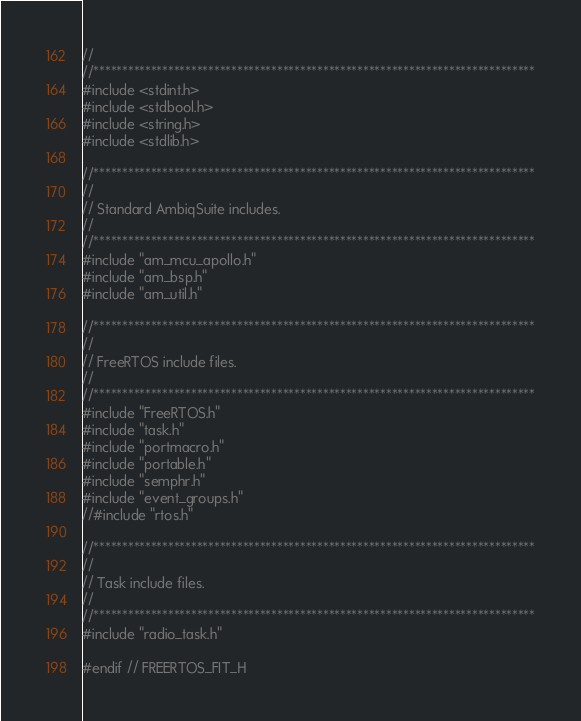<code> <loc_0><loc_0><loc_500><loc_500><_C_>//
//*****************************************************************************
#include <stdint.h>
#include <stdbool.h>
#include <string.h>
#include <stdlib.h>

//*****************************************************************************
//
// Standard AmbiqSuite includes.
//
//*****************************************************************************
#include "am_mcu_apollo.h"
#include "am_bsp.h"
#include "am_util.h"

//*****************************************************************************
//
// FreeRTOS include files.
//
//*****************************************************************************
#include "FreeRTOS.h"
#include "task.h"
#include "portmacro.h"
#include "portable.h"
#include "semphr.h"
#include "event_groups.h"
//#include "rtos.h"

//*****************************************************************************
//
// Task include files.
//
//*****************************************************************************
#include "radio_task.h"

#endif // FREERTOS_FIT_H
</code> 